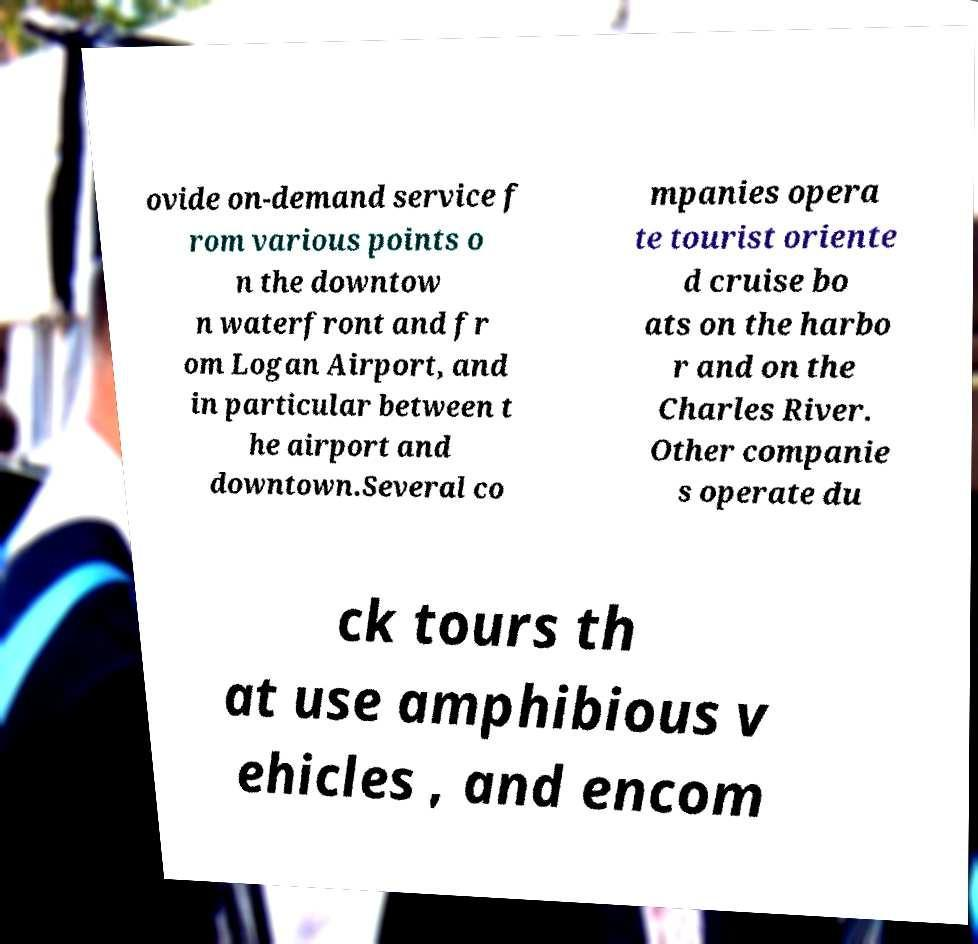Please identify and transcribe the text found in this image. ovide on-demand service f rom various points o n the downtow n waterfront and fr om Logan Airport, and in particular between t he airport and downtown.Several co mpanies opera te tourist oriente d cruise bo ats on the harbo r and on the Charles River. Other companie s operate du ck tours th at use amphibious v ehicles , and encom 